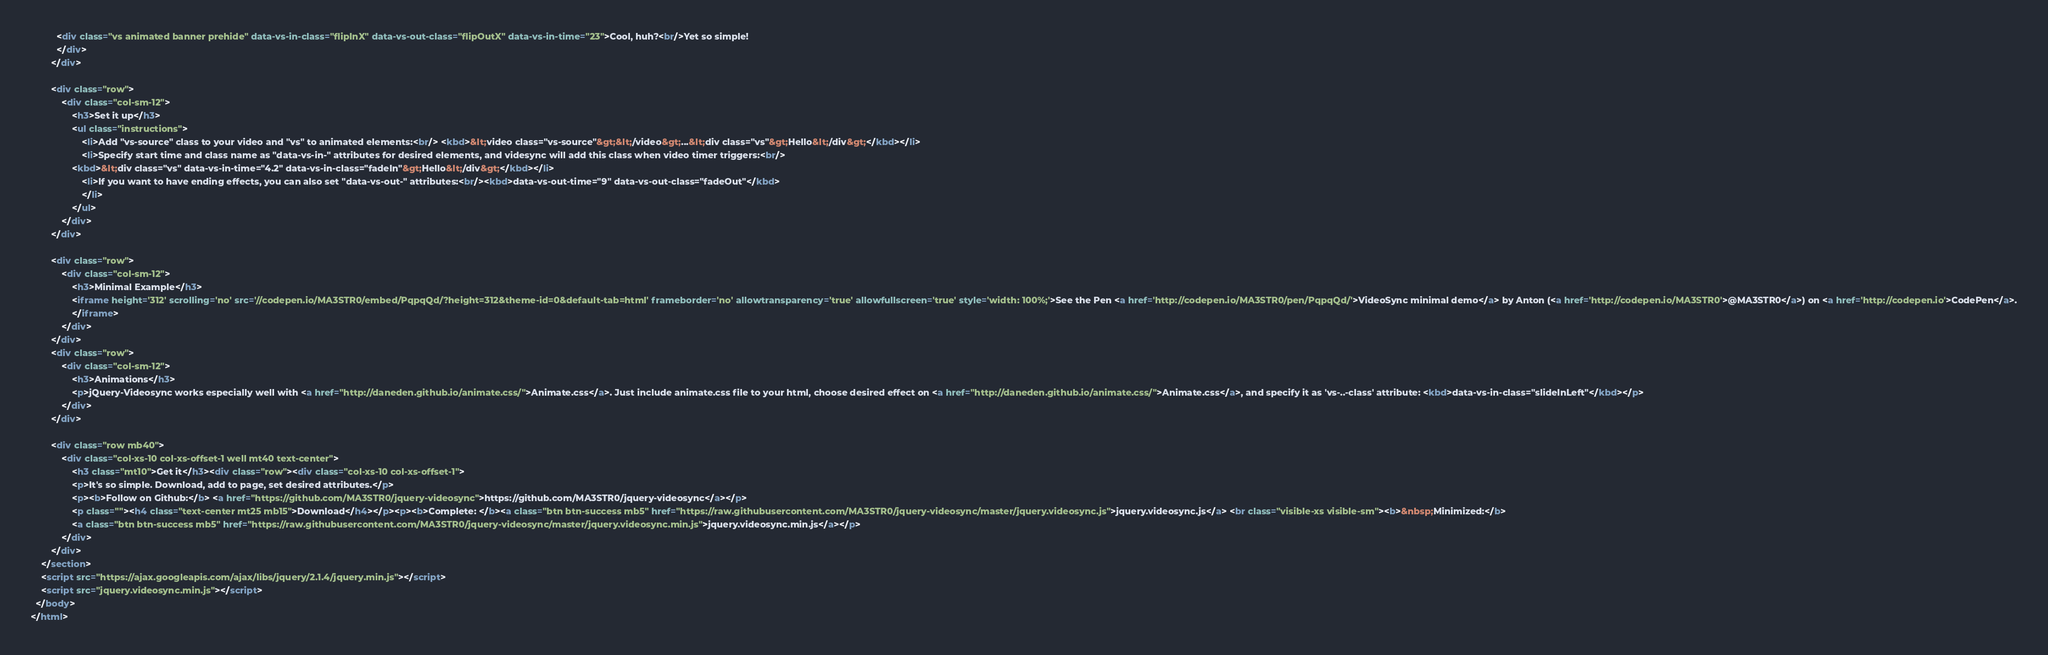<code> <loc_0><loc_0><loc_500><loc_500><_HTML_>          <div class="vs animated banner prehide" data-vs-in-class="flipInX" data-vs-out-class="flipOutX" data-vs-in-time="23">Cool, huh?<br/>Yet so simple!
          </div>
        </div>

        <div class="row">
            <div class="col-sm-12">
                <h3>Set it up</h3>
                <ul class="instructions">
                    <li>Add "vs-source" class to your video and "vs" to animated elements:<br/> <kbd>&lt;video class="vs-source"&gt;&lt;/video&gt;...&lt;div class="vs"&gt;Hello&lt;/div&gt;</kbd></li>
                    <li>Specify start time and class name as "data-vs-in-" attributes for desired elements, and videsync will add this class when video timer triggers:<br/>
                <kbd>&lt;div class="vs" data-vs-in-time="4.2" data-vs-in-class="fadeIn"&gt;Hello&lt;/div&gt;</kbd></li>
                    <li>If you want to have ending effects, you can also set "data-vs-out-" attributes:<br/><kbd>data-vs-out-time="9" data-vs-out-class="fadeOut"</kbd> 
                    </li>
                </ul>
            </div>
        </div>

        <div class="row">
            <div class="col-sm-12">
                <h3>Minimal Example</h3>
                <iframe height='312' scrolling='no' src='//codepen.io/MA3STR0/embed/PqpqQd/?height=312&theme-id=0&default-tab=html' frameborder='no' allowtransparency='true' allowfullscreen='true' style='width: 100%;'>See the Pen <a href='http://codepen.io/MA3STR0/pen/PqpqQd/'>VideoSync minimal demo</a> by Anton (<a href='http://codepen.io/MA3STR0'>@MA3STR0</a>) on <a href='http://codepen.io'>CodePen</a>.
                </iframe>
            </div>
        </div>
        <div class="row">
            <div class="col-sm-12">
                <h3>Animations</h3>
                <p>jQuery-Videosync works especially well with <a href="http://daneden.github.io/animate.css/">Animate.css</a>. Just include animate.css file to your html, choose desired effect on <a href="http://daneden.github.io/animate.css/">Animate.css</a>, and specify it as 'vs-..-class' attribute: <kbd>data-vs-in-class="slideInLeft"</kbd></p>
            </div>
        </div>

        <div class="row mb40">
            <div class="col-xs-10 col-xs-offset-1 well mt40 text-center">
                <h3 class="mt10">Get it</h3><div class="row"><div class="col-xs-10 col-xs-offset-1">
                <p>It's so simple. Download, add to page, set desired attributes.</p>
                <p><b>Follow on Github:</b> <a href="https://github.com/MA3STR0/jquery-videosync">https://github.com/MA3STR0/jquery-videosync</a></p>
                <p class=""><h4 class="text-center mt25 mb15">Download</h4></p><p><b>Complete: </b><a class="btn btn-success mb5" href="https://raw.githubusercontent.com/MA3STR0/jquery-videosync/master/jquery.videosync.js">jquery.videosync.js</a> <br class="visible-xs visible-sm"><b>&nbsp;Minimized:</b>
                <a class="btn btn-success mb5" href="https://raw.githubusercontent.com/MA3STR0/jquery-videosync/master/jquery.videosync.min.js">jquery.videosync.min.js</a></p>
            </div>
        </div>
    </section>
    <script src="https://ajax.googleapis.com/ajax/libs/jquery/2.1.4/jquery.min.js"></script>
    <script src="jquery.videosync.min.js"></script>
  </body>
</html>
</code> 